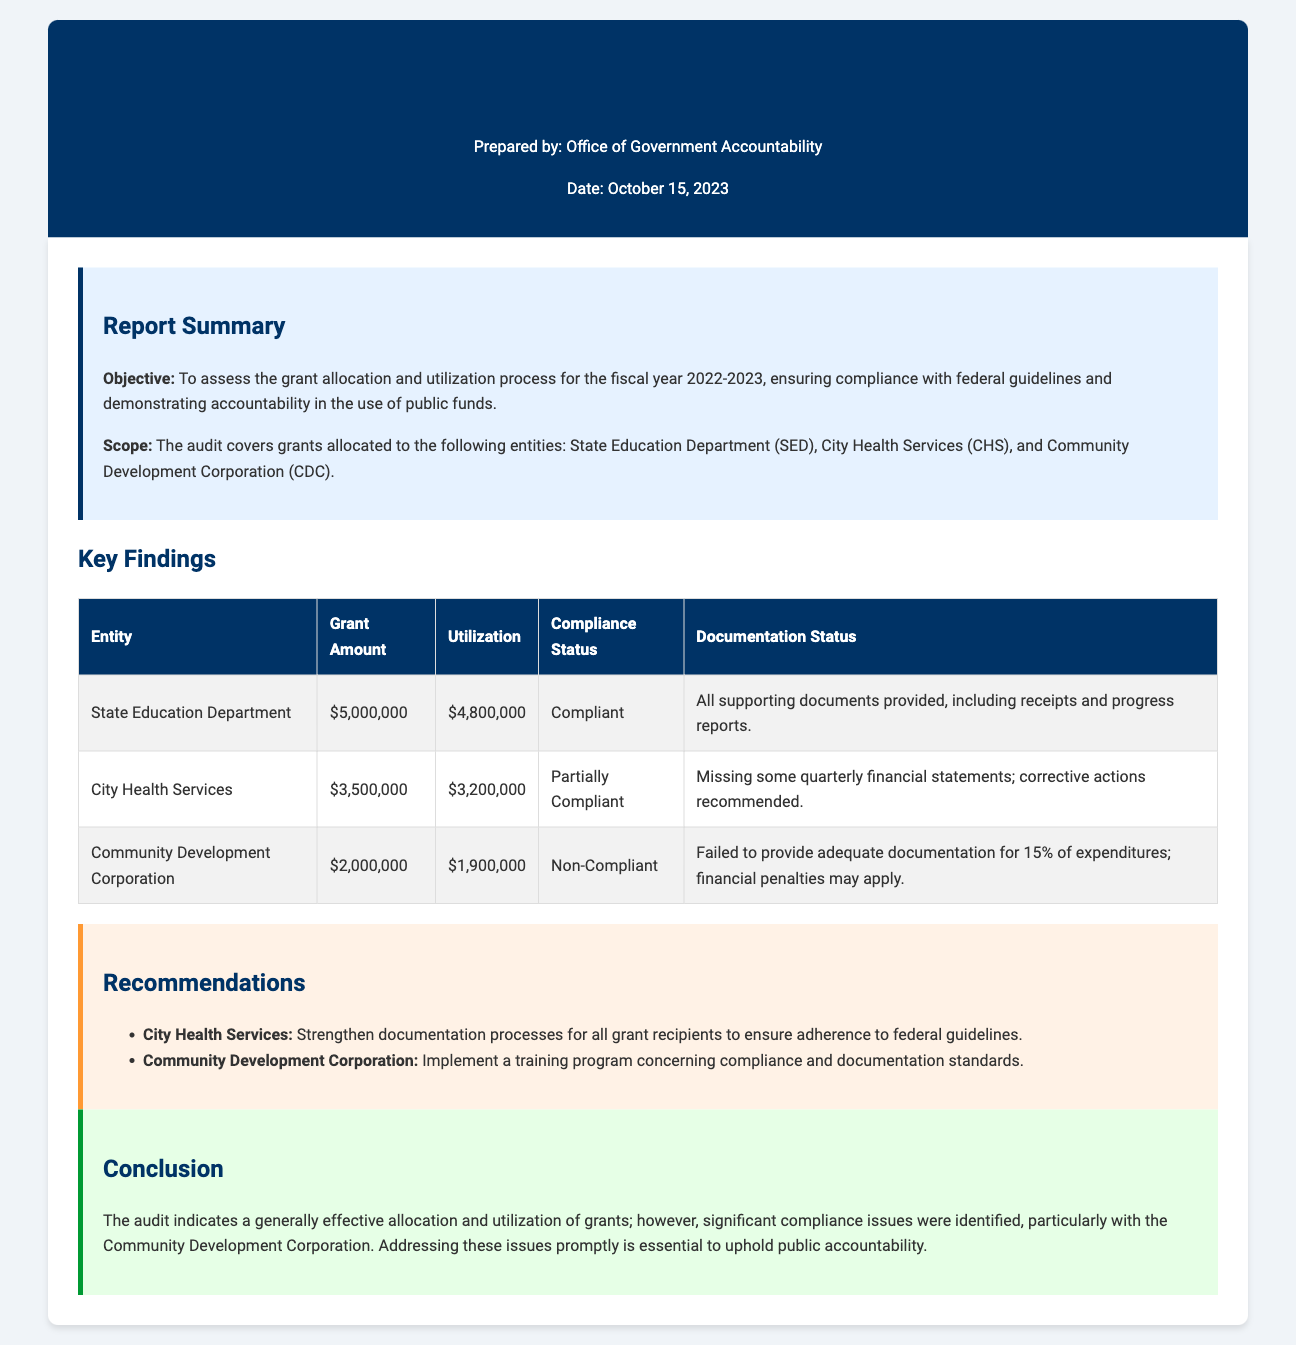what is the total grant amount allocated to the State Education Department? The total grant amount allocated is specified in the table, which lists $5,000,000 for the State Education Department.
Answer: $5,000,000 what is the utilization amount for City Health Services? The utilization amount for City Health Services is found in the table, which shows it as $3,200,000.
Answer: $3,200,000 what is the compliance status of the Community Development Corporation? The compliance status is mentioned in the findings table, indicating it is Non-Compliant.
Answer: Non-Compliant which entity has missing documentation for some expenditures? The document specifies that City Health Services is noted to have missing some quarterly financial statements.
Answer: City Health Services what percentage of expenditures does the Community Development Corporation lack adequate documentation for? The report states that it failed to provide adequate documentation for 15% of expenditures.
Answer: 15% what recommendations are given to City Health Services? The document lists a recommendation to strengthen documentation processes for all grant recipients to ensure adherence to federal guidelines.
Answer: Strengthen documentation processes what is the objective of the audit report? The objective of the audit report is outlined in the summary section, stating it is to assess the grant allocation and utilization process.
Answer: To assess the grant allocation and utilization process on what date was the audit report prepared? The preparation date of the audit report is provided in the header, which is October 15, 2023.
Answer: October 15, 2023 what is the main conclusion of the audit? The conclusion section summarizes the audit findings, stating that significant compliance issues were identified.
Answer: Significant compliance issues were identified 